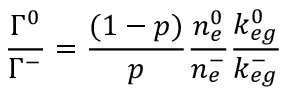Convert formula to latex. <formula><loc_0><loc_0><loc_500><loc_500>\frac { \Gamma ^ { 0 } } { \Gamma ^ { - } } = \frac { ( 1 - p ) } { p } \frac { n _ { e } ^ { 0 } } { n _ { e } ^ { - } } \frac { k _ { e g } ^ { 0 } } { k _ { e g } ^ { - } }</formula> 